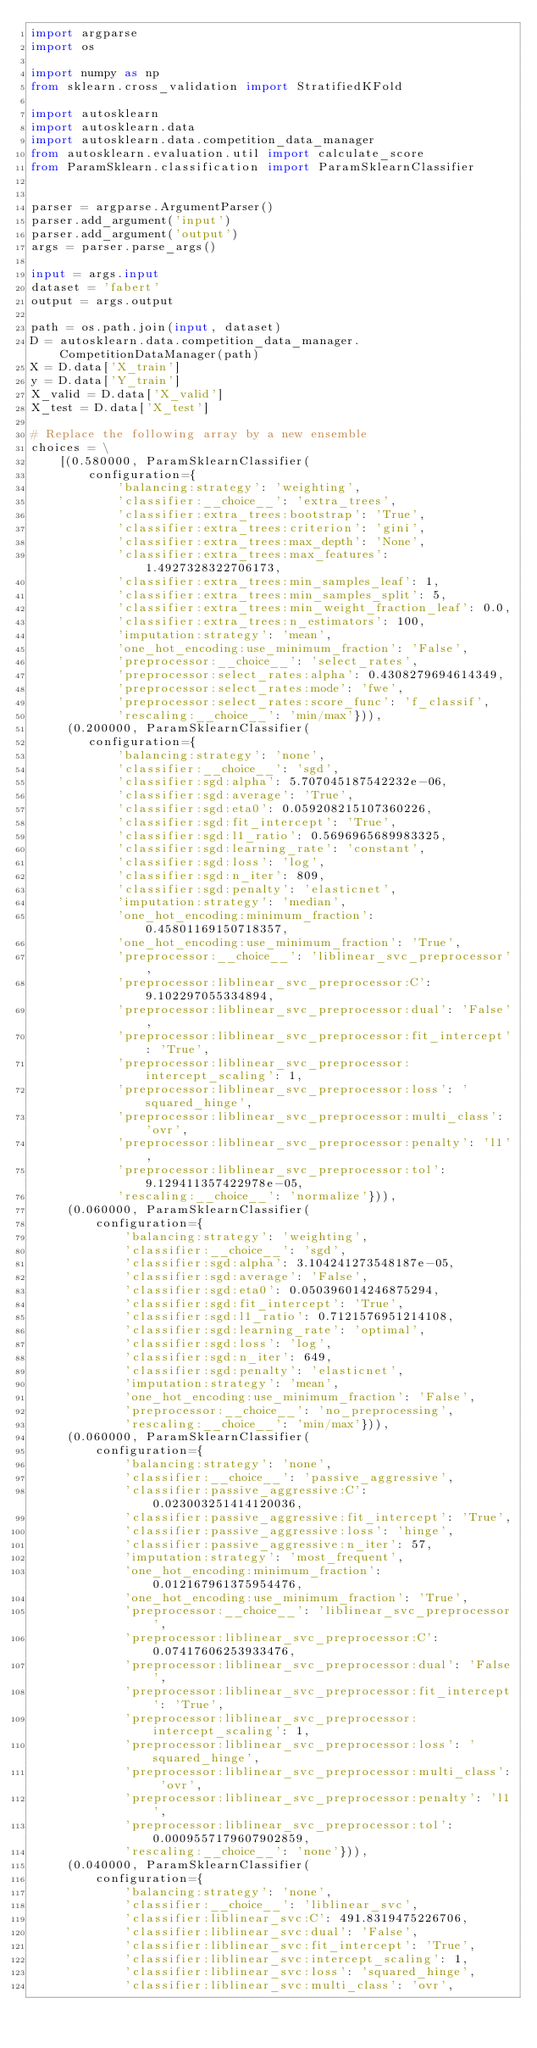Convert code to text. <code><loc_0><loc_0><loc_500><loc_500><_Python_>import argparse
import os

import numpy as np
from sklearn.cross_validation import StratifiedKFold

import autosklearn
import autosklearn.data
import autosklearn.data.competition_data_manager
from autosklearn.evaluation.util import calculate_score
from ParamSklearn.classification import ParamSklearnClassifier


parser = argparse.ArgumentParser()
parser.add_argument('input')
parser.add_argument('output')
args = parser.parse_args()

input = args.input
dataset = 'fabert'
output = args.output

path = os.path.join(input, dataset)
D = autosklearn.data.competition_data_manager.CompetitionDataManager(path)
X = D.data['X_train']
y = D.data['Y_train']
X_valid = D.data['X_valid']
X_test = D.data['X_test']

# Replace the following array by a new ensemble
choices = \
    [(0.580000, ParamSklearnClassifier(
        configuration={
            'balancing:strategy': 'weighting',
            'classifier:__choice__': 'extra_trees',
            'classifier:extra_trees:bootstrap': 'True',
            'classifier:extra_trees:criterion': 'gini',
            'classifier:extra_trees:max_depth': 'None',
            'classifier:extra_trees:max_features': 1.4927328322706173,
            'classifier:extra_trees:min_samples_leaf': 1,
            'classifier:extra_trees:min_samples_split': 5,
            'classifier:extra_trees:min_weight_fraction_leaf': 0.0,
            'classifier:extra_trees:n_estimators': 100,
            'imputation:strategy': 'mean',
            'one_hot_encoding:use_minimum_fraction': 'False',
            'preprocessor:__choice__': 'select_rates',
            'preprocessor:select_rates:alpha': 0.4308279694614349,
            'preprocessor:select_rates:mode': 'fwe',
            'preprocessor:select_rates:score_func': 'f_classif',
            'rescaling:__choice__': 'min/max'})),
     (0.200000, ParamSklearnClassifier(
        configuration={
            'balancing:strategy': 'none',
            'classifier:__choice__': 'sgd',
            'classifier:sgd:alpha': 5.707045187542232e-06,
            'classifier:sgd:average': 'True',
            'classifier:sgd:eta0': 0.059208215107360226,
            'classifier:sgd:fit_intercept': 'True',
            'classifier:sgd:l1_ratio': 0.5696965689983325,
            'classifier:sgd:learning_rate': 'constant',
            'classifier:sgd:loss': 'log',
            'classifier:sgd:n_iter': 809,
            'classifier:sgd:penalty': 'elasticnet',
            'imputation:strategy': 'median',
            'one_hot_encoding:minimum_fraction': 0.45801169150718357,
            'one_hot_encoding:use_minimum_fraction': 'True',
            'preprocessor:__choice__': 'liblinear_svc_preprocessor',
            'preprocessor:liblinear_svc_preprocessor:C': 9.102297055334894,
            'preprocessor:liblinear_svc_preprocessor:dual': 'False',
            'preprocessor:liblinear_svc_preprocessor:fit_intercept': 'True',
            'preprocessor:liblinear_svc_preprocessor:intercept_scaling': 1,
            'preprocessor:liblinear_svc_preprocessor:loss': 'squared_hinge',
            'preprocessor:liblinear_svc_preprocessor:multi_class': 'ovr',
            'preprocessor:liblinear_svc_preprocessor:penalty': 'l1',
            'preprocessor:liblinear_svc_preprocessor:tol': 9.129411357422978e-05,
            'rescaling:__choice__': 'normalize'})),
     (0.060000, ParamSklearnClassifier(
         configuration={
             'balancing:strategy': 'weighting',
             'classifier:__choice__': 'sgd',
             'classifier:sgd:alpha': 3.104241273548187e-05,
             'classifier:sgd:average': 'False',
             'classifier:sgd:eta0': 0.050396014246875294,
             'classifier:sgd:fit_intercept': 'True',
             'classifier:sgd:l1_ratio': 0.7121576951214108,
             'classifier:sgd:learning_rate': 'optimal',
             'classifier:sgd:loss': 'log',
             'classifier:sgd:n_iter': 649,
             'classifier:sgd:penalty': 'elasticnet',
             'imputation:strategy': 'mean',
             'one_hot_encoding:use_minimum_fraction': 'False',
             'preprocessor:__choice__': 'no_preprocessing',
             'rescaling:__choice__': 'min/max'})),
     (0.060000, ParamSklearnClassifier(
         configuration={
             'balancing:strategy': 'none',
             'classifier:__choice__': 'passive_aggressive',
             'classifier:passive_aggressive:C': 0.023003251414120036,
             'classifier:passive_aggressive:fit_intercept': 'True',
             'classifier:passive_aggressive:loss': 'hinge',
             'classifier:passive_aggressive:n_iter': 57,
             'imputation:strategy': 'most_frequent',
             'one_hot_encoding:minimum_fraction': 0.012167961375954476,
             'one_hot_encoding:use_minimum_fraction': 'True',
             'preprocessor:__choice__': 'liblinear_svc_preprocessor',
             'preprocessor:liblinear_svc_preprocessor:C': 0.07417606253933476,
             'preprocessor:liblinear_svc_preprocessor:dual': 'False',
             'preprocessor:liblinear_svc_preprocessor:fit_intercept': 'True',
             'preprocessor:liblinear_svc_preprocessor:intercept_scaling': 1,
             'preprocessor:liblinear_svc_preprocessor:loss': 'squared_hinge',
             'preprocessor:liblinear_svc_preprocessor:multi_class': 'ovr',
             'preprocessor:liblinear_svc_preprocessor:penalty': 'l1',
             'preprocessor:liblinear_svc_preprocessor:tol': 0.0009557179607902859,
             'rescaling:__choice__': 'none'})),
     (0.040000, ParamSklearnClassifier(
         configuration={
             'balancing:strategy': 'none',
             'classifier:__choice__': 'liblinear_svc',
             'classifier:liblinear_svc:C': 491.8319475226706,
             'classifier:liblinear_svc:dual': 'False',
             'classifier:liblinear_svc:fit_intercept': 'True',
             'classifier:liblinear_svc:intercept_scaling': 1,
             'classifier:liblinear_svc:loss': 'squared_hinge',
             'classifier:liblinear_svc:multi_class': 'ovr',</code> 